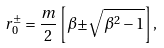Convert formula to latex. <formula><loc_0><loc_0><loc_500><loc_500>r _ { 0 } ^ { \pm } = \frac { m } { 2 } \left [ \beta { \pm } \sqrt { \beta ^ { 2 } - 1 } \right ] ,</formula> 